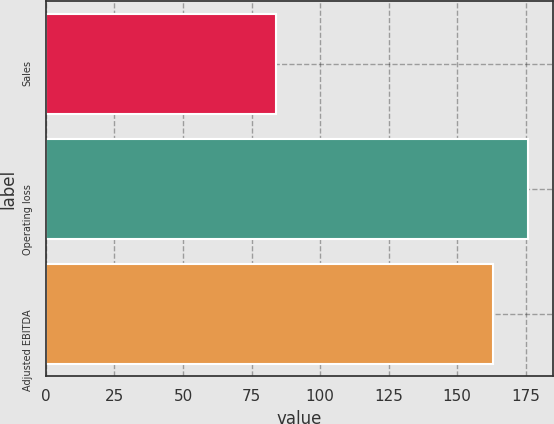<chart> <loc_0><loc_0><loc_500><loc_500><bar_chart><fcel>Sales<fcel>Operating loss<fcel>Adjusted EBITDA<nl><fcel>84<fcel>176<fcel>163.1<nl></chart> 